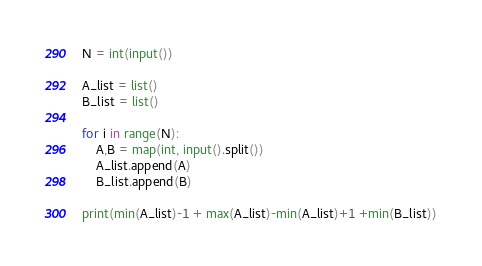<code> <loc_0><loc_0><loc_500><loc_500><_Python_>N = int(input())

A_list = list()
B_list = list()

for i in range(N):
    A,B = map(int, input().split())
    A_list.append(A)
    B_list.append(B)

print(min(A_list)-1 + max(A_list)-min(A_list)+1 +min(B_list))</code> 